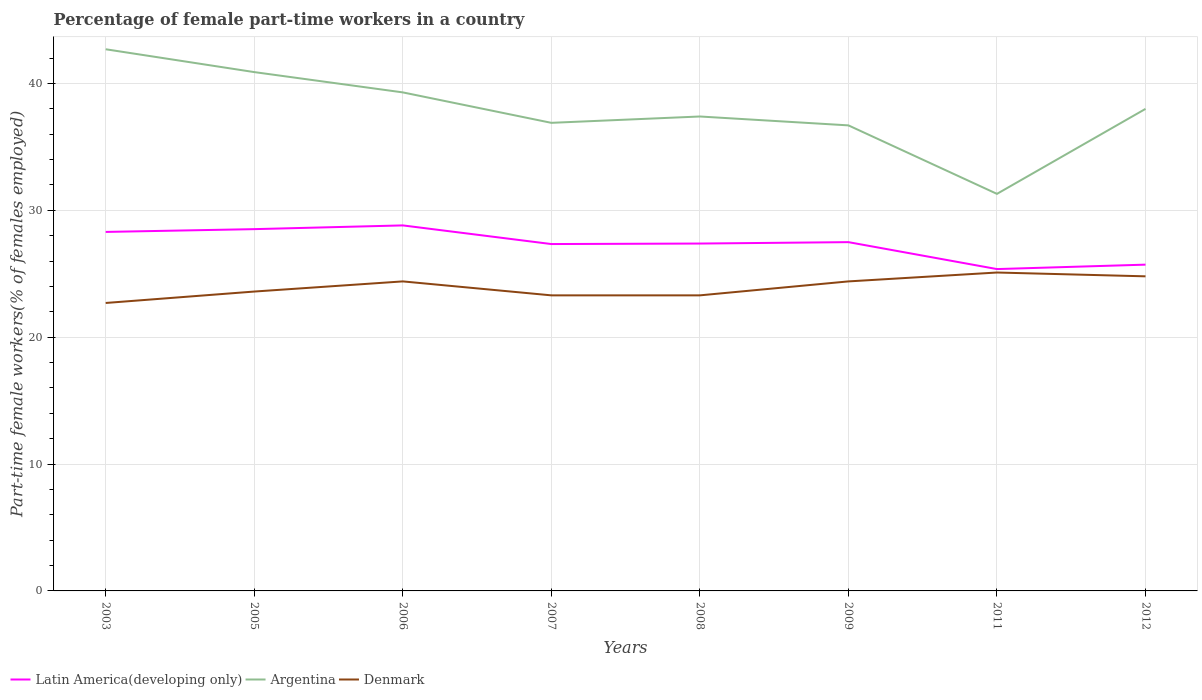How many different coloured lines are there?
Your answer should be compact. 3. Does the line corresponding to Denmark intersect with the line corresponding to Latin America(developing only)?
Give a very brief answer. No. Across all years, what is the maximum percentage of female part-time workers in Argentina?
Keep it short and to the point. 31.3. In which year was the percentage of female part-time workers in Argentina maximum?
Provide a short and direct response. 2011. What is the total percentage of female part-time workers in Denmark in the graph?
Your response must be concise. 0.3. What is the difference between the highest and the second highest percentage of female part-time workers in Latin America(developing only)?
Offer a terse response. 3.44. Is the percentage of female part-time workers in Latin America(developing only) strictly greater than the percentage of female part-time workers in Argentina over the years?
Make the answer very short. Yes. How many lines are there?
Provide a short and direct response. 3. How many years are there in the graph?
Offer a terse response. 8. Does the graph contain any zero values?
Your response must be concise. No. Does the graph contain grids?
Keep it short and to the point. Yes. Where does the legend appear in the graph?
Ensure brevity in your answer.  Bottom left. How are the legend labels stacked?
Your answer should be compact. Horizontal. What is the title of the graph?
Make the answer very short. Percentage of female part-time workers in a country. Does "Russian Federation" appear as one of the legend labels in the graph?
Keep it short and to the point. No. What is the label or title of the X-axis?
Your answer should be very brief. Years. What is the label or title of the Y-axis?
Your answer should be very brief. Part-time female workers(% of females employed). What is the Part-time female workers(% of females employed) in Latin America(developing only) in 2003?
Offer a terse response. 28.3. What is the Part-time female workers(% of females employed) in Argentina in 2003?
Provide a short and direct response. 42.7. What is the Part-time female workers(% of females employed) in Denmark in 2003?
Offer a terse response. 22.7. What is the Part-time female workers(% of females employed) in Latin America(developing only) in 2005?
Your answer should be very brief. 28.52. What is the Part-time female workers(% of females employed) in Argentina in 2005?
Your answer should be very brief. 40.9. What is the Part-time female workers(% of females employed) in Denmark in 2005?
Your response must be concise. 23.6. What is the Part-time female workers(% of females employed) of Latin America(developing only) in 2006?
Your answer should be compact. 28.81. What is the Part-time female workers(% of females employed) in Argentina in 2006?
Provide a succinct answer. 39.3. What is the Part-time female workers(% of females employed) in Denmark in 2006?
Make the answer very short. 24.4. What is the Part-time female workers(% of females employed) of Latin America(developing only) in 2007?
Your answer should be compact. 27.34. What is the Part-time female workers(% of females employed) of Argentina in 2007?
Your answer should be compact. 36.9. What is the Part-time female workers(% of females employed) of Denmark in 2007?
Make the answer very short. 23.3. What is the Part-time female workers(% of females employed) in Latin America(developing only) in 2008?
Offer a very short reply. 27.38. What is the Part-time female workers(% of females employed) of Argentina in 2008?
Your response must be concise. 37.4. What is the Part-time female workers(% of females employed) in Denmark in 2008?
Offer a terse response. 23.3. What is the Part-time female workers(% of females employed) of Latin America(developing only) in 2009?
Give a very brief answer. 27.49. What is the Part-time female workers(% of females employed) in Argentina in 2009?
Offer a terse response. 36.7. What is the Part-time female workers(% of females employed) of Denmark in 2009?
Offer a terse response. 24.4. What is the Part-time female workers(% of females employed) in Latin America(developing only) in 2011?
Offer a terse response. 25.37. What is the Part-time female workers(% of females employed) in Argentina in 2011?
Offer a very short reply. 31.3. What is the Part-time female workers(% of females employed) of Denmark in 2011?
Make the answer very short. 25.1. What is the Part-time female workers(% of females employed) of Latin America(developing only) in 2012?
Provide a succinct answer. 25.72. What is the Part-time female workers(% of females employed) of Denmark in 2012?
Provide a short and direct response. 24.8. Across all years, what is the maximum Part-time female workers(% of females employed) of Latin America(developing only)?
Offer a terse response. 28.81. Across all years, what is the maximum Part-time female workers(% of females employed) in Argentina?
Provide a succinct answer. 42.7. Across all years, what is the maximum Part-time female workers(% of females employed) in Denmark?
Keep it short and to the point. 25.1. Across all years, what is the minimum Part-time female workers(% of females employed) in Latin America(developing only)?
Your answer should be very brief. 25.37. Across all years, what is the minimum Part-time female workers(% of females employed) of Argentina?
Your response must be concise. 31.3. Across all years, what is the minimum Part-time female workers(% of females employed) of Denmark?
Provide a succinct answer. 22.7. What is the total Part-time female workers(% of females employed) of Latin America(developing only) in the graph?
Your answer should be compact. 218.95. What is the total Part-time female workers(% of females employed) in Argentina in the graph?
Provide a succinct answer. 303.2. What is the total Part-time female workers(% of females employed) of Denmark in the graph?
Your answer should be compact. 191.6. What is the difference between the Part-time female workers(% of females employed) of Latin America(developing only) in 2003 and that in 2005?
Make the answer very short. -0.22. What is the difference between the Part-time female workers(% of females employed) of Denmark in 2003 and that in 2005?
Provide a short and direct response. -0.9. What is the difference between the Part-time female workers(% of females employed) in Latin America(developing only) in 2003 and that in 2006?
Provide a short and direct response. -0.51. What is the difference between the Part-time female workers(% of females employed) of Latin America(developing only) in 2003 and that in 2007?
Provide a succinct answer. 0.96. What is the difference between the Part-time female workers(% of females employed) of Argentina in 2003 and that in 2007?
Provide a succinct answer. 5.8. What is the difference between the Part-time female workers(% of females employed) in Latin America(developing only) in 2003 and that in 2008?
Provide a succinct answer. 0.92. What is the difference between the Part-time female workers(% of females employed) in Denmark in 2003 and that in 2008?
Offer a terse response. -0.6. What is the difference between the Part-time female workers(% of females employed) in Latin America(developing only) in 2003 and that in 2009?
Your answer should be very brief. 0.81. What is the difference between the Part-time female workers(% of females employed) in Argentina in 2003 and that in 2009?
Offer a very short reply. 6. What is the difference between the Part-time female workers(% of females employed) of Denmark in 2003 and that in 2009?
Make the answer very short. -1.7. What is the difference between the Part-time female workers(% of females employed) of Latin America(developing only) in 2003 and that in 2011?
Offer a very short reply. 2.93. What is the difference between the Part-time female workers(% of females employed) in Latin America(developing only) in 2003 and that in 2012?
Give a very brief answer. 2.58. What is the difference between the Part-time female workers(% of females employed) in Argentina in 2003 and that in 2012?
Offer a very short reply. 4.7. What is the difference between the Part-time female workers(% of females employed) of Denmark in 2003 and that in 2012?
Ensure brevity in your answer.  -2.1. What is the difference between the Part-time female workers(% of females employed) of Latin America(developing only) in 2005 and that in 2006?
Make the answer very short. -0.29. What is the difference between the Part-time female workers(% of females employed) of Latin America(developing only) in 2005 and that in 2007?
Your response must be concise. 1.18. What is the difference between the Part-time female workers(% of females employed) of Latin America(developing only) in 2005 and that in 2008?
Your response must be concise. 1.14. What is the difference between the Part-time female workers(% of females employed) of Argentina in 2005 and that in 2008?
Provide a short and direct response. 3.5. What is the difference between the Part-time female workers(% of females employed) of Latin America(developing only) in 2005 and that in 2009?
Give a very brief answer. 1.03. What is the difference between the Part-time female workers(% of females employed) of Argentina in 2005 and that in 2009?
Provide a short and direct response. 4.2. What is the difference between the Part-time female workers(% of females employed) in Denmark in 2005 and that in 2009?
Provide a short and direct response. -0.8. What is the difference between the Part-time female workers(% of females employed) in Latin America(developing only) in 2005 and that in 2011?
Provide a short and direct response. 3.15. What is the difference between the Part-time female workers(% of females employed) of Latin America(developing only) in 2005 and that in 2012?
Offer a terse response. 2.8. What is the difference between the Part-time female workers(% of females employed) of Argentina in 2005 and that in 2012?
Your response must be concise. 2.9. What is the difference between the Part-time female workers(% of females employed) in Denmark in 2005 and that in 2012?
Offer a very short reply. -1.2. What is the difference between the Part-time female workers(% of females employed) of Latin America(developing only) in 2006 and that in 2007?
Your answer should be very brief. 1.47. What is the difference between the Part-time female workers(% of females employed) in Denmark in 2006 and that in 2007?
Keep it short and to the point. 1.1. What is the difference between the Part-time female workers(% of females employed) in Latin America(developing only) in 2006 and that in 2008?
Your answer should be compact. 1.43. What is the difference between the Part-time female workers(% of females employed) in Latin America(developing only) in 2006 and that in 2009?
Give a very brief answer. 1.32. What is the difference between the Part-time female workers(% of females employed) of Latin America(developing only) in 2006 and that in 2011?
Provide a short and direct response. 3.44. What is the difference between the Part-time female workers(% of females employed) in Argentina in 2006 and that in 2011?
Your answer should be very brief. 8. What is the difference between the Part-time female workers(% of females employed) in Denmark in 2006 and that in 2011?
Offer a terse response. -0.7. What is the difference between the Part-time female workers(% of females employed) in Latin America(developing only) in 2006 and that in 2012?
Make the answer very short. 3.09. What is the difference between the Part-time female workers(% of females employed) of Argentina in 2006 and that in 2012?
Offer a very short reply. 1.3. What is the difference between the Part-time female workers(% of females employed) in Latin America(developing only) in 2007 and that in 2008?
Your answer should be compact. -0.04. What is the difference between the Part-time female workers(% of females employed) in Denmark in 2007 and that in 2008?
Offer a very short reply. 0. What is the difference between the Part-time female workers(% of females employed) of Argentina in 2007 and that in 2009?
Give a very brief answer. 0.2. What is the difference between the Part-time female workers(% of females employed) in Latin America(developing only) in 2007 and that in 2011?
Keep it short and to the point. 1.97. What is the difference between the Part-time female workers(% of females employed) of Latin America(developing only) in 2007 and that in 2012?
Ensure brevity in your answer.  1.62. What is the difference between the Part-time female workers(% of females employed) in Latin America(developing only) in 2008 and that in 2009?
Offer a very short reply. -0.11. What is the difference between the Part-time female workers(% of females employed) of Argentina in 2008 and that in 2009?
Your answer should be very brief. 0.7. What is the difference between the Part-time female workers(% of females employed) in Denmark in 2008 and that in 2009?
Provide a succinct answer. -1.1. What is the difference between the Part-time female workers(% of females employed) in Latin America(developing only) in 2008 and that in 2011?
Ensure brevity in your answer.  2.01. What is the difference between the Part-time female workers(% of females employed) of Argentina in 2008 and that in 2011?
Give a very brief answer. 6.1. What is the difference between the Part-time female workers(% of females employed) in Latin America(developing only) in 2008 and that in 2012?
Provide a succinct answer. 1.66. What is the difference between the Part-time female workers(% of females employed) in Denmark in 2008 and that in 2012?
Your response must be concise. -1.5. What is the difference between the Part-time female workers(% of females employed) of Latin America(developing only) in 2009 and that in 2011?
Provide a succinct answer. 2.12. What is the difference between the Part-time female workers(% of females employed) of Argentina in 2009 and that in 2011?
Make the answer very short. 5.4. What is the difference between the Part-time female workers(% of females employed) of Latin America(developing only) in 2009 and that in 2012?
Give a very brief answer. 1.77. What is the difference between the Part-time female workers(% of females employed) in Argentina in 2009 and that in 2012?
Provide a short and direct response. -1.3. What is the difference between the Part-time female workers(% of females employed) of Denmark in 2009 and that in 2012?
Offer a very short reply. -0.4. What is the difference between the Part-time female workers(% of females employed) in Latin America(developing only) in 2011 and that in 2012?
Your answer should be very brief. -0.35. What is the difference between the Part-time female workers(% of females employed) of Argentina in 2011 and that in 2012?
Offer a terse response. -6.7. What is the difference between the Part-time female workers(% of females employed) in Denmark in 2011 and that in 2012?
Your answer should be compact. 0.3. What is the difference between the Part-time female workers(% of females employed) of Latin America(developing only) in 2003 and the Part-time female workers(% of females employed) of Argentina in 2005?
Offer a very short reply. -12.6. What is the difference between the Part-time female workers(% of females employed) of Latin America(developing only) in 2003 and the Part-time female workers(% of females employed) of Denmark in 2005?
Ensure brevity in your answer.  4.7. What is the difference between the Part-time female workers(% of females employed) of Latin America(developing only) in 2003 and the Part-time female workers(% of females employed) of Argentina in 2006?
Ensure brevity in your answer.  -11. What is the difference between the Part-time female workers(% of females employed) of Latin America(developing only) in 2003 and the Part-time female workers(% of females employed) of Denmark in 2006?
Your answer should be compact. 3.9. What is the difference between the Part-time female workers(% of females employed) in Argentina in 2003 and the Part-time female workers(% of females employed) in Denmark in 2006?
Your answer should be very brief. 18.3. What is the difference between the Part-time female workers(% of females employed) in Latin America(developing only) in 2003 and the Part-time female workers(% of females employed) in Argentina in 2007?
Offer a very short reply. -8.6. What is the difference between the Part-time female workers(% of females employed) in Latin America(developing only) in 2003 and the Part-time female workers(% of females employed) in Denmark in 2007?
Ensure brevity in your answer.  5. What is the difference between the Part-time female workers(% of females employed) in Latin America(developing only) in 2003 and the Part-time female workers(% of females employed) in Argentina in 2008?
Offer a very short reply. -9.1. What is the difference between the Part-time female workers(% of females employed) in Latin America(developing only) in 2003 and the Part-time female workers(% of females employed) in Denmark in 2008?
Provide a succinct answer. 5. What is the difference between the Part-time female workers(% of females employed) in Argentina in 2003 and the Part-time female workers(% of females employed) in Denmark in 2008?
Provide a short and direct response. 19.4. What is the difference between the Part-time female workers(% of females employed) of Latin America(developing only) in 2003 and the Part-time female workers(% of females employed) of Argentina in 2009?
Offer a terse response. -8.4. What is the difference between the Part-time female workers(% of females employed) of Latin America(developing only) in 2003 and the Part-time female workers(% of females employed) of Denmark in 2009?
Provide a succinct answer. 3.9. What is the difference between the Part-time female workers(% of females employed) in Latin America(developing only) in 2003 and the Part-time female workers(% of females employed) in Argentina in 2011?
Provide a succinct answer. -3. What is the difference between the Part-time female workers(% of females employed) in Latin America(developing only) in 2003 and the Part-time female workers(% of females employed) in Denmark in 2011?
Ensure brevity in your answer.  3.2. What is the difference between the Part-time female workers(% of females employed) in Latin America(developing only) in 2003 and the Part-time female workers(% of females employed) in Argentina in 2012?
Provide a succinct answer. -9.7. What is the difference between the Part-time female workers(% of females employed) of Latin America(developing only) in 2003 and the Part-time female workers(% of females employed) of Denmark in 2012?
Offer a very short reply. 3.5. What is the difference between the Part-time female workers(% of females employed) in Argentina in 2003 and the Part-time female workers(% of females employed) in Denmark in 2012?
Provide a succinct answer. 17.9. What is the difference between the Part-time female workers(% of females employed) in Latin America(developing only) in 2005 and the Part-time female workers(% of females employed) in Argentina in 2006?
Provide a short and direct response. -10.78. What is the difference between the Part-time female workers(% of females employed) of Latin America(developing only) in 2005 and the Part-time female workers(% of females employed) of Denmark in 2006?
Keep it short and to the point. 4.12. What is the difference between the Part-time female workers(% of females employed) in Latin America(developing only) in 2005 and the Part-time female workers(% of females employed) in Argentina in 2007?
Ensure brevity in your answer.  -8.38. What is the difference between the Part-time female workers(% of females employed) in Latin America(developing only) in 2005 and the Part-time female workers(% of females employed) in Denmark in 2007?
Provide a short and direct response. 5.22. What is the difference between the Part-time female workers(% of females employed) of Latin America(developing only) in 2005 and the Part-time female workers(% of females employed) of Argentina in 2008?
Provide a succinct answer. -8.88. What is the difference between the Part-time female workers(% of females employed) in Latin America(developing only) in 2005 and the Part-time female workers(% of females employed) in Denmark in 2008?
Your answer should be compact. 5.22. What is the difference between the Part-time female workers(% of females employed) of Latin America(developing only) in 2005 and the Part-time female workers(% of females employed) of Argentina in 2009?
Make the answer very short. -8.18. What is the difference between the Part-time female workers(% of females employed) in Latin America(developing only) in 2005 and the Part-time female workers(% of females employed) in Denmark in 2009?
Offer a very short reply. 4.12. What is the difference between the Part-time female workers(% of females employed) of Argentina in 2005 and the Part-time female workers(% of females employed) of Denmark in 2009?
Ensure brevity in your answer.  16.5. What is the difference between the Part-time female workers(% of females employed) in Latin America(developing only) in 2005 and the Part-time female workers(% of females employed) in Argentina in 2011?
Provide a short and direct response. -2.78. What is the difference between the Part-time female workers(% of females employed) of Latin America(developing only) in 2005 and the Part-time female workers(% of females employed) of Denmark in 2011?
Ensure brevity in your answer.  3.42. What is the difference between the Part-time female workers(% of females employed) of Argentina in 2005 and the Part-time female workers(% of females employed) of Denmark in 2011?
Give a very brief answer. 15.8. What is the difference between the Part-time female workers(% of females employed) of Latin America(developing only) in 2005 and the Part-time female workers(% of females employed) of Argentina in 2012?
Make the answer very short. -9.48. What is the difference between the Part-time female workers(% of females employed) of Latin America(developing only) in 2005 and the Part-time female workers(% of females employed) of Denmark in 2012?
Ensure brevity in your answer.  3.72. What is the difference between the Part-time female workers(% of females employed) in Argentina in 2005 and the Part-time female workers(% of females employed) in Denmark in 2012?
Give a very brief answer. 16.1. What is the difference between the Part-time female workers(% of females employed) of Latin America(developing only) in 2006 and the Part-time female workers(% of females employed) of Argentina in 2007?
Provide a succinct answer. -8.09. What is the difference between the Part-time female workers(% of females employed) in Latin America(developing only) in 2006 and the Part-time female workers(% of females employed) in Denmark in 2007?
Offer a very short reply. 5.51. What is the difference between the Part-time female workers(% of females employed) in Argentina in 2006 and the Part-time female workers(% of females employed) in Denmark in 2007?
Your answer should be very brief. 16. What is the difference between the Part-time female workers(% of females employed) of Latin America(developing only) in 2006 and the Part-time female workers(% of females employed) of Argentina in 2008?
Offer a very short reply. -8.59. What is the difference between the Part-time female workers(% of females employed) of Latin America(developing only) in 2006 and the Part-time female workers(% of females employed) of Denmark in 2008?
Provide a short and direct response. 5.51. What is the difference between the Part-time female workers(% of females employed) of Argentina in 2006 and the Part-time female workers(% of females employed) of Denmark in 2008?
Ensure brevity in your answer.  16. What is the difference between the Part-time female workers(% of females employed) of Latin America(developing only) in 2006 and the Part-time female workers(% of females employed) of Argentina in 2009?
Offer a terse response. -7.89. What is the difference between the Part-time female workers(% of females employed) in Latin America(developing only) in 2006 and the Part-time female workers(% of females employed) in Denmark in 2009?
Make the answer very short. 4.41. What is the difference between the Part-time female workers(% of females employed) in Latin America(developing only) in 2006 and the Part-time female workers(% of females employed) in Argentina in 2011?
Give a very brief answer. -2.49. What is the difference between the Part-time female workers(% of females employed) of Latin America(developing only) in 2006 and the Part-time female workers(% of females employed) of Denmark in 2011?
Keep it short and to the point. 3.71. What is the difference between the Part-time female workers(% of females employed) in Argentina in 2006 and the Part-time female workers(% of females employed) in Denmark in 2011?
Provide a succinct answer. 14.2. What is the difference between the Part-time female workers(% of females employed) in Latin America(developing only) in 2006 and the Part-time female workers(% of females employed) in Argentina in 2012?
Make the answer very short. -9.19. What is the difference between the Part-time female workers(% of females employed) in Latin America(developing only) in 2006 and the Part-time female workers(% of females employed) in Denmark in 2012?
Offer a terse response. 4.01. What is the difference between the Part-time female workers(% of females employed) of Latin America(developing only) in 2007 and the Part-time female workers(% of females employed) of Argentina in 2008?
Your answer should be very brief. -10.06. What is the difference between the Part-time female workers(% of females employed) in Latin America(developing only) in 2007 and the Part-time female workers(% of females employed) in Denmark in 2008?
Make the answer very short. 4.04. What is the difference between the Part-time female workers(% of females employed) of Latin America(developing only) in 2007 and the Part-time female workers(% of females employed) of Argentina in 2009?
Offer a very short reply. -9.36. What is the difference between the Part-time female workers(% of females employed) of Latin America(developing only) in 2007 and the Part-time female workers(% of females employed) of Denmark in 2009?
Your answer should be very brief. 2.94. What is the difference between the Part-time female workers(% of females employed) in Latin America(developing only) in 2007 and the Part-time female workers(% of females employed) in Argentina in 2011?
Make the answer very short. -3.96. What is the difference between the Part-time female workers(% of females employed) in Latin America(developing only) in 2007 and the Part-time female workers(% of females employed) in Denmark in 2011?
Your answer should be compact. 2.24. What is the difference between the Part-time female workers(% of females employed) of Latin America(developing only) in 2007 and the Part-time female workers(% of females employed) of Argentina in 2012?
Make the answer very short. -10.66. What is the difference between the Part-time female workers(% of females employed) of Latin America(developing only) in 2007 and the Part-time female workers(% of females employed) of Denmark in 2012?
Offer a terse response. 2.54. What is the difference between the Part-time female workers(% of females employed) of Argentina in 2007 and the Part-time female workers(% of females employed) of Denmark in 2012?
Your response must be concise. 12.1. What is the difference between the Part-time female workers(% of females employed) of Latin America(developing only) in 2008 and the Part-time female workers(% of females employed) of Argentina in 2009?
Offer a very short reply. -9.32. What is the difference between the Part-time female workers(% of females employed) of Latin America(developing only) in 2008 and the Part-time female workers(% of females employed) of Denmark in 2009?
Make the answer very short. 2.98. What is the difference between the Part-time female workers(% of females employed) of Latin America(developing only) in 2008 and the Part-time female workers(% of females employed) of Argentina in 2011?
Offer a very short reply. -3.92. What is the difference between the Part-time female workers(% of females employed) of Latin America(developing only) in 2008 and the Part-time female workers(% of females employed) of Denmark in 2011?
Make the answer very short. 2.28. What is the difference between the Part-time female workers(% of females employed) in Argentina in 2008 and the Part-time female workers(% of females employed) in Denmark in 2011?
Ensure brevity in your answer.  12.3. What is the difference between the Part-time female workers(% of females employed) in Latin America(developing only) in 2008 and the Part-time female workers(% of females employed) in Argentina in 2012?
Give a very brief answer. -10.62. What is the difference between the Part-time female workers(% of females employed) in Latin America(developing only) in 2008 and the Part-time female workers(% of females employed) in Denmark in 2012?
Your response must be concise. 2.58. What is the difference between the Part-time female workers(% of females employed) in Latin America(developing only) in 2009 and the Part-time female workers(% of females employed) in Argentina in 2011?
Give a very brief answer. -3.81. What is the difference between the Part-time female workers(% of females employed) in Latin America(developing only) in 2009 and the Part-time female workers(% of females employed) in Denmark in 2011?
Offer a terse response. 2.39. What is the difference between the Part-time female workers(% of females employed) in Argentina in 2009 and the Part-time female workers(% of females employed) in Denmark in 2011?
Make the answer very short. 11.6. What is the difference between the Part-time female workers(% of females employed) in Latin America(developing only) in 2009 and the Part-time female workers(% of females employed) in Argentina in 2012?
Make the answer very short. -10.51. What is the difference between the Part-time female workers(% of females employed) of Latin America(developing only) in 2009 and the Part-time female workers(% of females employed) of Denmark in 2012?
Your answer should be very brief. 2.69. What is the difference between the Part-time female workers(% of females employed) of Latin America(developing only) in 2011 and the Part-time female workers(% of females employed) of Argentina in 2012?
Keep it short and to the point. -12.63. What is the difference between the Part-time female workers(% of females employed) of Latin America(developing only) in 2011 and the Part-time female workers(% of females employed) of Denmark in 2012?
Offer a terse response. 0.57. What is the difference between the Part-time female workers(% of females employed) of Argentina in 2011 and the Part-time female workers(% of females employed) of Denmark in 2012?
Ensure brevity in your answer.  6.5. What is the average Part-time female workers(% of females employed) of Latin America(developing only) per year?
Offer a very short reply. 27.37. What is the average Part-time female workers(% of females employed) in Argentina per year?
Give a very brief answer. 37.9. What is the average Part-time female workers(% of females employed) of Denmark per year?
Provide a short and direct response. 23.95. In the year 2003, what is the difference between the Part-time female workers(% of females employed) of Latin America(developing only) and Part-time female workers(% of females employed) of Argentina?
Your answer should be very brief. -14.4. In the year 2003, what is the difference between the Part-time female workers(% of females employed) of Latin America(developing only) and Part-time female workers(% of females employed) of Denmark?
Provide a succinct answer. 5.6. In the year 2005, what is the difference between the Part-time female workers(% of females employed) of Latin America(developing only) and Part-time female workers(% of females employed) of Argentina?
Your answer should be very brief. -12.38. In the year 2005, what is the difference between the Part-time female workers(% of females employed) in Latin America(developing only) and Part-time female workers(% of females employed) in Denmark?
Ensure brevity in your answer.  4.92. In the year 2005, what is the difference between the Part-time female workers(% of females employed) in Argentina and Part-time female workers(% of females employed) in Denmark?
Offer a very short reply. 17.3. In the year 2006, what is the difference between the Part-time female workers(% of females employed) in Latin America(developing only) and Part-time female workers(% of females employed) in Argentina?
Your response must be concise. -10.49. In the year 2006, what is the difference between the Part-time female workers(% of females employed) of Latin America(developing only) and Part-time female workers(% of females employed) of Denmark?
Your answer should be compact. 4.41. In the year 2007, what is the difference between the Part-time female workers(% of females employed) in Latin America(developing only) and Part-time female workers(% of females employed) in Argentina?
Your response must be concise. -9.56. In the year 2007, what is the difference between the Part-time female workers(% of females employed) in Latin America(developing only) and Part-time female workers(% of females employed) in Denmark?
Provide a succinct answer. 4.04. In the year 2007, what is the difference between the Part-time female workers(% of females employed) of Argentina and Part-time female workers(% of females employed) of Denmark?
Offer a very short reply. 13.6. In the year 2008, what is the difference between the Part-time female workers(% of females employed) of Latin America(developing only) and Part-time female workers(% of females employed) of Argentina?
Provide a succinct answer. -10.02. In the year 2008, what is the difference between the Part-time female workers(% of females employed) of Latin America(developing only) and Part-time female workers(% of females employed) of Denmark?
Provide a succinct answer. 4.08. In the year 2009, what is the difference between the Part-time female workers(% of females employed) of Latin America(developing only) and Part-time female workers(% of females employed) of Argentina?
Make the answer very short. -9.21. In the year 2009, what is the difference between the Part-time female workers(% of females employed) in Latin America(developing only) and Part-time female workers(% of females employed) in Denmark?
Your answer should be compact. 3.09. In the year 2011, what is the difference between the Part-time female workers(% of females employed) of Latin America(developing only) and Part-time female workers(% of females employed) of Argentina?
Provide a short and direct response. -5.93. In the year 2011, what is the difference between the Part-time female workers(% of females employed) of Latin America(developing only) and Part-time female workers(% of females employed) of Denmark?
Provide a short and direct response. 0.27. In the year 2012, what is the difference between the Part-time female workers(% of females employed) in Latin America(developing only) and Part-time female workers(% of females employed) in Argentina?
Offer a very short reply. -12.28. In the year 2012, what is the difference between the Part-time female workers(% of females employed) in Latin America(developing only) and Part-time female workers(% of females employed) in Denmark?
Provide a succinct answer. 0.92. In the year 2012, what is the difference between the Part-time female workers(% of females employed) of Argentina and Part-time female workers(% of females employed) of Denmark?
Make the answer very short. 13.2. What is the ratio of the Part-time female workers(% of females employed) in Argentina in 2003 to that in 2005?
Offer a very short reply. 1.04. What is the ratio of the Part-time female workers(% of females employed) of Denmark in 2003 to that in 2005?
Offer a very short reply. 0.96. What is the ratio of the Part-time female workers(% of females employed) in Latin America(developing only) in 2003 to that in 2006?
Give a very brief answer. 0.98. What is the ratio of the Part-time female workers(% of females employed) of Argentina in 2003 to that in 2006?
Offer a terse response. 1.09. What is the ratio of the Part-time female workers(% of females employed) of Denmark in 2003 to that in 2006?
Your answer should be compact. 0.93. What is the ratio of the Part-time female workers(% of females employed) in Latin America(developing only) in 2003 to that in 2007?
Your answer should be compact. 1.03. What is the ratio of the Part-time female workers(% of females employed) in Argentina in 2003 to that in 2007?
Your answer should be compact. 1.16. What is the ratio of the Part-time female workers(% of females employed) of Denmark in 2003 to that in 2007?
Offer a very short reply. 0.97. What is the ratio of the Part-time female workers(% of females employed) of Latin America(developing only) in 2003 to that in 2008?
Your answer should be very brief. 1.03. What is the ratio of the Part-time female workers(% of females employed) of Argentina in 2003 to that in 2008?
Keep it short and to the point. 1.14. What is the ratio of the Part-time female workers(% of females employed) of Denmark in 2003 to that in 2008?
Make the answer very short. 0.97. What is the ratio of the Part-time female workers(% of females employed) in Latin America(developing only) in 2003 to that in 2009?
Ensure brevity in your answer.  1.03. What is the ratio of the Part-time female workers(% of females employed) in Argentina in 2003 to that in 2009?
Keep it short and to the point. 1.16. What is the ratio of the Part-time female workers(% of females employed) of Denmark in 2003 to that in 2009?
Offer a terse response. 0.93. What is the ratio of the Part-time female workers(% of females employed) in Latin America(developing only) in 2003 to that in 2011?
Provide a short and direct response. 1.12. What is the ratio of the Part-time female workers(% of females employed) of Argentina in 2003 to that in 2011?
Ensure brevity in your answer.  1.36. What is the ratio of the Part-time female workers(% of females employed) in Denmark in 2003 to that in 2011?
Make the answer very short. 0.9. What is the ratio of the Part-time female workers(% of females employed) in Latin America(developing only) in 2003 to that in 2012?
Your response must be concise. 1.1. What is the ratio of the Part-time female workers(% of females employed) in Argentina in 2003 to that in 2012?
Give a very brief answer. 1.12. What is the ratio of the Part-time female workers(% of females employed) in Denmark in 2003 to that in 2012?
Ensure brevity in your answer.  0.92. What is the ratio of the Part-time female workers(% of females employed) of Argentina in 2005 to that in 2006?
Offer a terse response. 1.04. What is the ratio of the Part-time female workers(% of females employed) of Denmark in 2005 to that in 2006?
Ensure brevity in your answer.  0.97. What is the ratio of the Part-time female workers(% of females employed) of Latin America(developing only) in 2005 to that in 2007?
Your answer should be very brief. 1.04. What is the ratio of the Part-time female workers(% of females employed) in Argentina in 2005 to that in 2007?
Offer a terse response. 1.11. What is the ratio of the Part-time female workers(% of females employed) of Denmark in 2005 to that in 2007?
Your answer should be compact. 1.01. What is the ratio of the Part-time female workers(% of females employed) in Latin America(developing only) in 2005 to that in 2008?
Provide a succinct answer. 1.04. What is the ratio of the Part-time female workers(% of females employed) in Argentina in 2005 to that in 2008?
Your answer should be compact. 1.09. What is the ratio of the Part-time female workers(% of females employed) in Denmark in 2005 to that in 2008?
Your answer should be compact. 1.01. What is the ratio of the Part-time female workers(% of females employed) of Latin America(developing only) in 2005 to that in 2009?
Your answer should be very brief. 1.04. What is the ratio of the Part-time female workers(% of females employed) in Argentina in 2005 to that in 2009?
Ensure brevity in your answer.  1.11. What is the ratio of the Part-time female workers(% of females employed) in Denmark in 2005 to that in 2009?
Provide a succinct answer. 0.97. What is the ratio of the Part-time female workers(% of females employed) in Latin America(developing only) in 2005 to that in 2011?
Offer a terse response. 1.12. What is the ratio of the Part-time female workers(% of females employed) in Argentina in 2005 to that in 2011?
Offer a very short reply. 1.31. What is the ratio of the Part-time female workers(% of females employed) of Denmark in 2005 to that in 2011?
Provide a succinct answer. 0.94. What is the ratio of the Part-time female workers(% of females employed) of Latin America(developing only) in 2005 to that in 2012?
Your response must be concise. 1.11. What is the ratio of the Part-time female workers(% of females employed) in Argentina in 2005 to that in 2012?
Your answer should be very brief. 1.08. What is the ratio of the Part-time female workers(% of females employed) of Denmark in 2005 to that in 2012?
Keep it short and to the point. 0.95. What is the ratio of the Part-time female workers(% of females employed) in Latin America(developing only) in 2006 to that in 2007?
Offer a terse response. 1.05. What is the ratio of the Part-time female workers(% of females employed) of Argentina in 2006 to that in 2007?
Give a very brief answer. 1.06. What is the ratio of the Part-time female workers(% of females employed) of Denmark in 2006 to that in 2007?
Your answer should be very brief. 1.05. What is the ratio of the Part-time female workers(% of females employed) in Latin America(developing only) in 2006 to that in 2008?
Your answer should be compact. 1.05. What is the ratio of the Part-time female workers(% of females employed) of Argentina in 2006 to that in 2008?
Your answer should be compact. 1.05. What is the ratio of the Part-time female workers(% of females employed) in Denmark in 2006 to that in 2008?
Your response must be concise. 1.05. What is the ratio of the Part-time female workers(% of females employed) of Latin America(developing only) in 2006 to that in 2009?
Give a very brief answer. 1.05. What is the ratio of the Part-time female workers(% of females employed) of Argentina in 2006 to that in 2009?
Offer a terse response. 1.07. What is the ratio of the Part-time female workers(% of females employed) in Denmark in 2006 to that in 2009?
Keep it short and to the point. 1. What is the ratio of the Part-time female workers(% of females employed) in Latin America(developing only) in 2006 to that in 2011?
Your answer should be compact. 1.14. What is the ratio of the Part-time female workers(% of females employed) of Argentina in 2006 to that in 2011?
Make the answer very short. 1.26. What is the ratio of the Part-time female workers(% of females employed) in Denmark in 2006 to that in 2011?
Provide a succinct answer. 0.97. What is the ratio of the Part-time female workers(% of females employed) of Latin America(developing only) in 2006 to that in 2012?
Keep it short and to the point. 1.12. What is the ratio of the Part-time female workers(% of females employed) in Argentina in 2006 to that in 2012?
Your answer should be very brief. 1.03. What is the ratio of the Part-time female workers(% of females employed) of Denmark in 2006 to that in 2012?
Give a very brief answer. 0.98. What is the ratio of the Part-time female workers(% of females employed) in Argentina in 2007 to that in 2008?
Provide a short and direct response. 0.99. What is the ratio of the Part-time female workers(% of females employed) of Argentina in 2007 to that in 2009?
Ensure brevity in your answer.  1.01. What is the ratio of the Part-time female workers(% of females employed) in Denmark in 2007 to that in 2009?
Your answer should be compact. 0.95. What is the ratio of the Part-time female workers(% of females employed) in Latin America(developing only) in 2007 to that in 2011?
Give a very brief answer. 1.08. What is the ratio of the Part-time female workers(% of females employed) of Argentina in 2007 to that in 2011?
Give a very brief answer. 1.18. What is the ratio of the Part-time female workers(% of females employed) in Denmark in 2007 to that in 2011?
Give a very brief answer. 0.93. What is the ratio of the Part-time female workers(% of females employed) in Latin America(developing only) in 2007 to that in 2012?
Offer a terse response. 1.06. What is the ratio of the Part-time female workers(% of females employed) in Argentina in 2007 to that in 2012?
Your answer should be compact. 0.97. What is the ratio of the Part-time female workers(% of females employed) in Denmark in 2007 to that in 2012?
Your answer should be very brief. 0.94. What is the ratio of the Part-time female workers(% of females employed) in Latin America(developing only) in 2008 to that in 2009?
Your response must be concise. 1. What is the ratio of the Part-time female workers(% of females employed) in Argentina in 2008 to that in 2009?
Offer a terse response. 1.02. What is the ratio of the Part-time female workers(% of females employed) of Denmark in 2008 to that in 2009?
Your answer should be compact. 0.95. What is the ratio of the Part-time female workers(% of females employed) of Latin America(developing only) in 2008 to that in 2011?
Your answer should be very brief. 1.08. What is the ratio of the Part-time female workers(% of females employed) in Argentina in 2008 to that in 2011?
Offer a terse response. 1.19. What is the ratio of the Part-time female workers(% of females employed) in Denmark in 2008 to that in 2011?
Give a very brief answer. 0.93. What is the ratio of the Part-time female workers(% of females employed) of Latin America(developing only) in 2008 to that in 2012?
Offer a terse response. 1.06. What is the ratio of the Part-time female workers(% of females employed) in Argentina in 2008 to that in 2012?
Your answer should be compact. 0.98. What is the ratio of the Part-time female workers(% of females employed) of Denmark in 2008 to that in 2012?
Provide a succinct answer. 0.94. What is the ratio of the Part-time female workers(% of females employed) in Latin America(developing only) in 2009 to that in 2011?
Offer a terse response. 1.08. What is the ratio of the Part-time female workers(% of females employed) of Argentina in 2009 to that in 2011?
Make the answer very short. 1.17. What is the ratio of the Part-time female workers(% of females employed) of Denmark in 2009 to that in 2011?
Make the answer very short. 0.97. What is the ratio of the Part-time female workers(% of females employed) of Latin America(developing only) in 2009 to that in 2012?
Your answer should be compact. 1.07. What is the ratio of the Part-time female workers(% of females employed) of Argentina in 2009 to that in 2012?
Make the answer very short. 0.97. What is the ratio of the Part-time female workers(% of females employed) in Denmark in 2009 to that in 2012?
Offer a terse response. 0.98. What is the ratio of the Part-time female workers(% of females employed) in Latin America(developing only) in 2011 to that in 2012?
Provide a succinct answer. 0.99. What is the ratio of the Part-time female workers(% of females employed) of Argentina in 2011 to that in 2012?
Your response must be concise. 0.82. What is the ratio of the Part-time female workers(% of females employed) in Denmark in 2011 to that in 2012?
Provide a short and direct response. 1.01. What is the difference between the highest and the second highest Part-time female workers(% of females employed) in Latin America(developing only)?
Your answer should be very brief. 0.29. What is the difference between the highest and the lowest Part-time female workers(% of females employed) in Latin America(developing only)?
Make the answer very short. 3.44. What is the difference between the highest and the lowest Part-time female workers(% of females employed) of Argentina?
Offer a terse response. 11.4. What is the difference between the highest and the lowest Part-time female workers(% of females employed) of Denmark?
Your response must be concise. 2.4. 